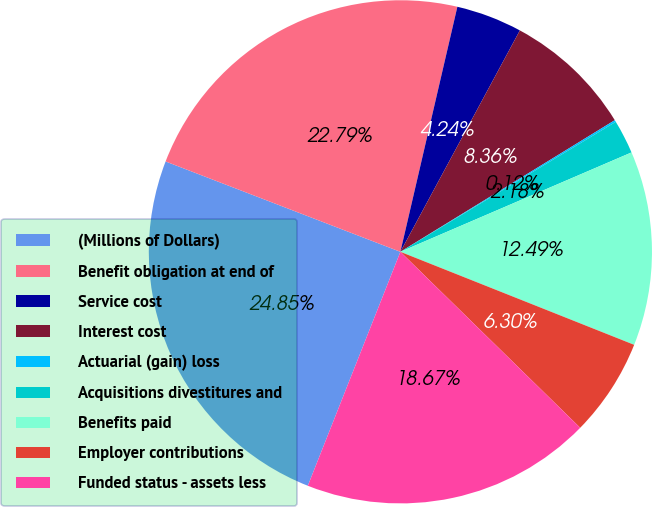<chart> <loc_0><loc_0><loc_500><loc_500><pie_chart><fcel>(Millions of Dollars)<fcel>Benefit obligation at end of<fcel>Service cost<fcel>Interest cost<fcel>Actuarial (gain) loss<fcel>Acquisitions divestitures and<fcel>Benefits paid<fcel>Employer contributions<fcel>Funded status - assets less<nl><fcel>24.85%<fcel>22.79%<fcel>4.24%<fcel>8.36%<fcel>0.12%<fcel>2.18%<fcel>12.49%<fcel>6.3%<fcel>18.67%<nl></chart> 